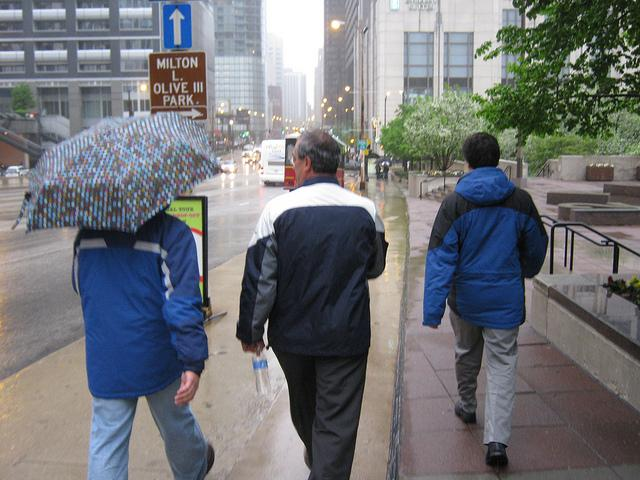What type of area is shown? sidewalk 